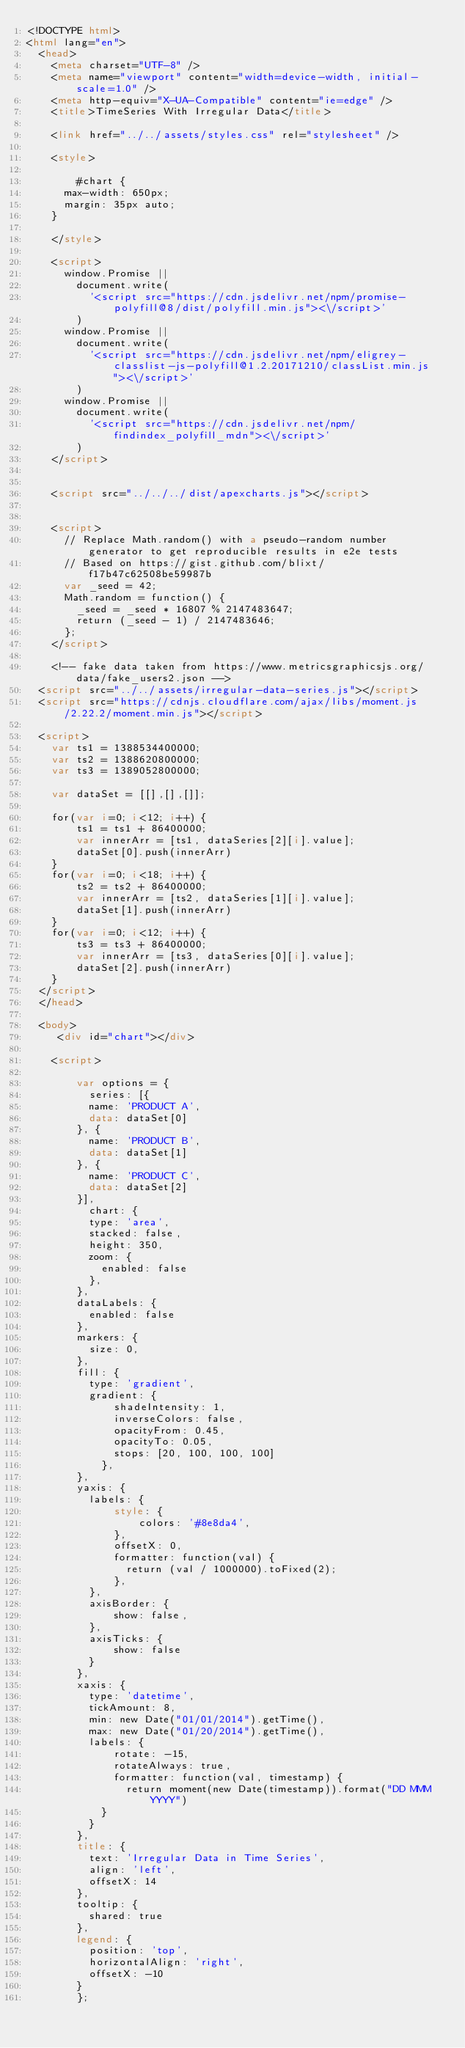<code> <loc_0><loc_0><loc_500><loc_500><_HTML_><!DOCTYPE html>
<html lang="en">
  <head>
    <meta charset="UTF-8" />
    <meta name="viewport" content="width=device-width, initial-scale=1.0" />
    <meta http-equiv="X-UA-Compatible" content="ie=edge" />
    <title>TimeSeries With Irregular Data</title>

    <link href="../../assets/styles.css" rel="stylesheet" />

    <style>
      
        #chart {
      max-width: 650px;
      margin: 35px auto;
    }
      
    </style>

    <script>
      window.Promise ||
        document.write(
          '<script src="https://cdn.jsdelivr.net/npm/promise-polyfill@8/dist/polyfill.min.js"><\/script>'
        )
      window.Promise ||
        document.write(
          '<script src="https://cdn.jsdelivr.net/npm/eligrey-classlist-js-polyfill@1.2.20171210/classList.min.js"><\/script>'
        )
      window.Promise ||
        document.write(
          '<script src="https://cdn.jsdelivr.net/npm/findindex_polyfill_mdn"><\/script>'
        )
    </script>

    
    <script src="../../../dist/apexcharts.js"></script>
    

    <script>
      // Replace Math.random() with a pseudo-random number generator to get reproducible results in e2e tests
      // Based on https://gist.github.com/blixt/f17b47c62508be59987b
      var _seed = 42;
      Math.random = function() {
        _seed = _seed * 16807 % 2147483647;
        return (_seed - 1) / 2147483646;
      };
    </script>

    <!-- fake data taken from https://www.metricsgraphicsjs.org/data/fake_users2.json -->
  <script src="../../assets/irregular-data-series.js"></script>
  <script src="https://cdnjs.cloudflare.com/ajax/libs/moment.js/2.22.2/moment.min.js"></script>
  
  <script>
    var ts1 = 1388534400000;
    var ts2 = 1388620800000;
    var ts3 = 1389052800000;
  
    var dataSet = [[],[],[]];
  
    for(var i=0; i<12; i++) {
        ts1 = ts1 + 86400000;
        var innerArr = [ts1, dataSeries[2][i].value];
        dataSet[0].push(innerArr)
    }
    for(var i=0; i<18; i++) {
        ts2 = ts2 + 86400000;
        var innerArr = [ts2, dataSeries[1][i].value];
        dataSet[1].push(innerArr)
    }
    for(var i=0; i<12; i++) {
        ts3 = ts3 + 86400000;
        var innerArr = [ts3, dataSeries[0][i].value];
        dataSet[2].push(innerArr)
    }
  </script>
  </head>

  <body>
     <div id="chart"></div>

    <script>
      
        var options = {
          series: [{
          name: 'PRODUCT A',
          data: dataSet[0]
        }, {
          name: 'PRODUCT B',
          data: dataSet[1]
        }, {
          name: 'PRODUCT C',
          data: dataSet[2]
        }],
          chart: {
          type: 'area',
          stacked: false,
          height: 350,
          zoom: {
            enabled: false
          },
        },
        dataLabels: {
          enabled: false
        },
        markers: {
          size: 0,
        },
        fill: {
          type: 'gradient',
          gradient: {
              shadeIntensity: 1,
              inverseColors: false,
              opacityFrom: 0.45,
              opacityTo: 0.05,
              stops: [20, 100, 100, 100]
            },
        },
        yaxis: {
          labels: {
              style: {
                  colors: '#8e8da4',
              },
              offsetX: 0,
              formatter: function(val) {
                return (val / 1000000).toFixed(2);
              },
          },
          axisBorder: {
              show: false,
          },
          axisTicks: {
              show: false
          }
        },
        xaxis: {
          type: 'datetime',
          tickAmount: 8,
          min: new Date("01/01/2014").getTime(),
          max: new Date("01/20/2014").getTime(),
          labels: {
              rotate: -15,
              rotateAlways: true,
              formatter: function(val, timestamp) {
                return moment(new Date(timestamp)).format("DD MMM YYYY")
            }
          }
        },
        title: {
          text: 'Irregular Data in Time Series',
          align: 'left',
          offsetX: 14
        },
        tooltip: {
          shared: true
        },
        legend: {
          position: 'top',
          horizontalAlign: 'right',
          offsetX: -10
        }
        };
</code> 